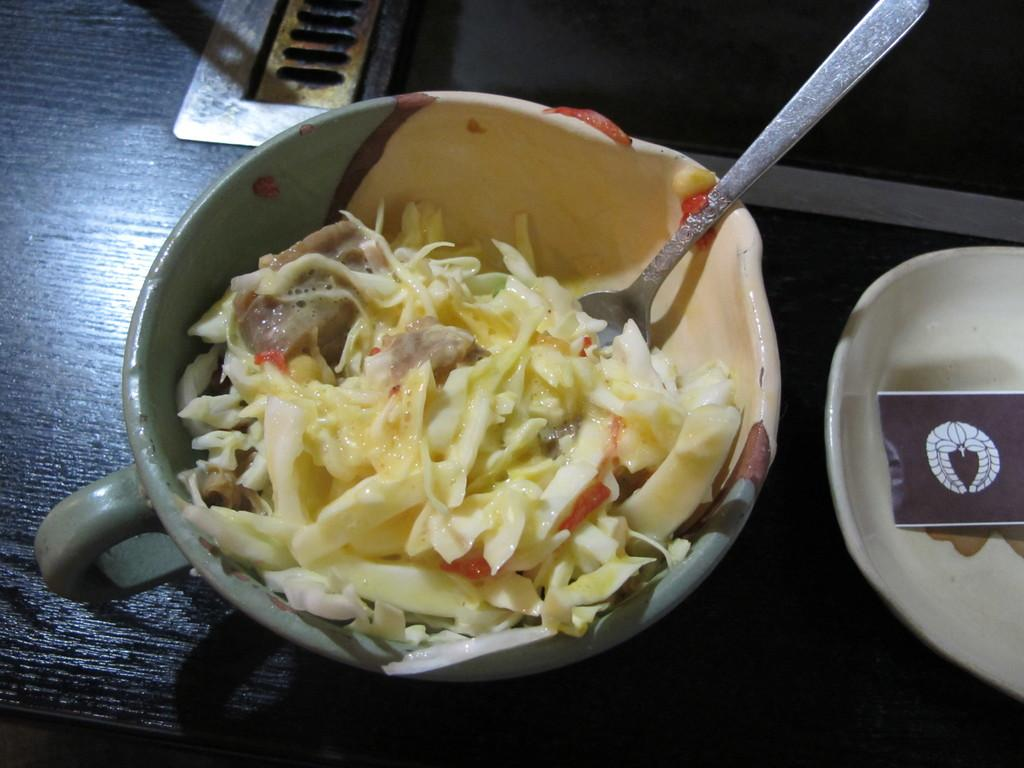How many bowls are visible in the image? There are two bowls in the image. What is in one of the bowls? One bowl contains food. What is used to eat the food in the bowl? A spoon is present in the bowl with food. What is in the other bowl? The other bowl contains an unspecified object. What is the expert's opinion on the condition of the shoe in the image? There is no expert or shoe present in the image, so it is not possible to answer that question. 